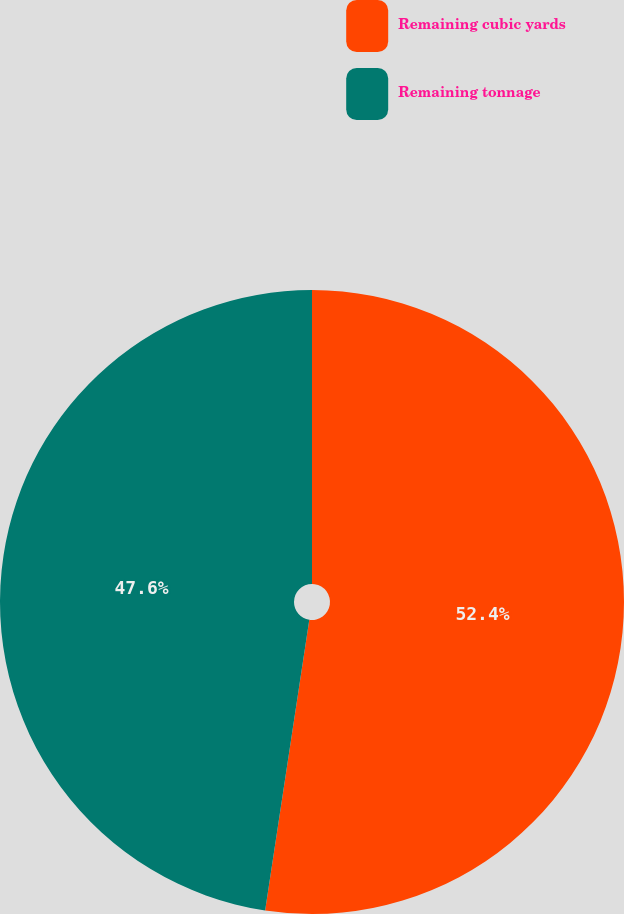<chart> <loc_0><loc_0><loc_500><loc_500><pie_chart><fcel>Remaining cubic yards<fcel>Remaining tonnage<nl><fcel>52.4%<fcel>47.6%<nl></chart> 